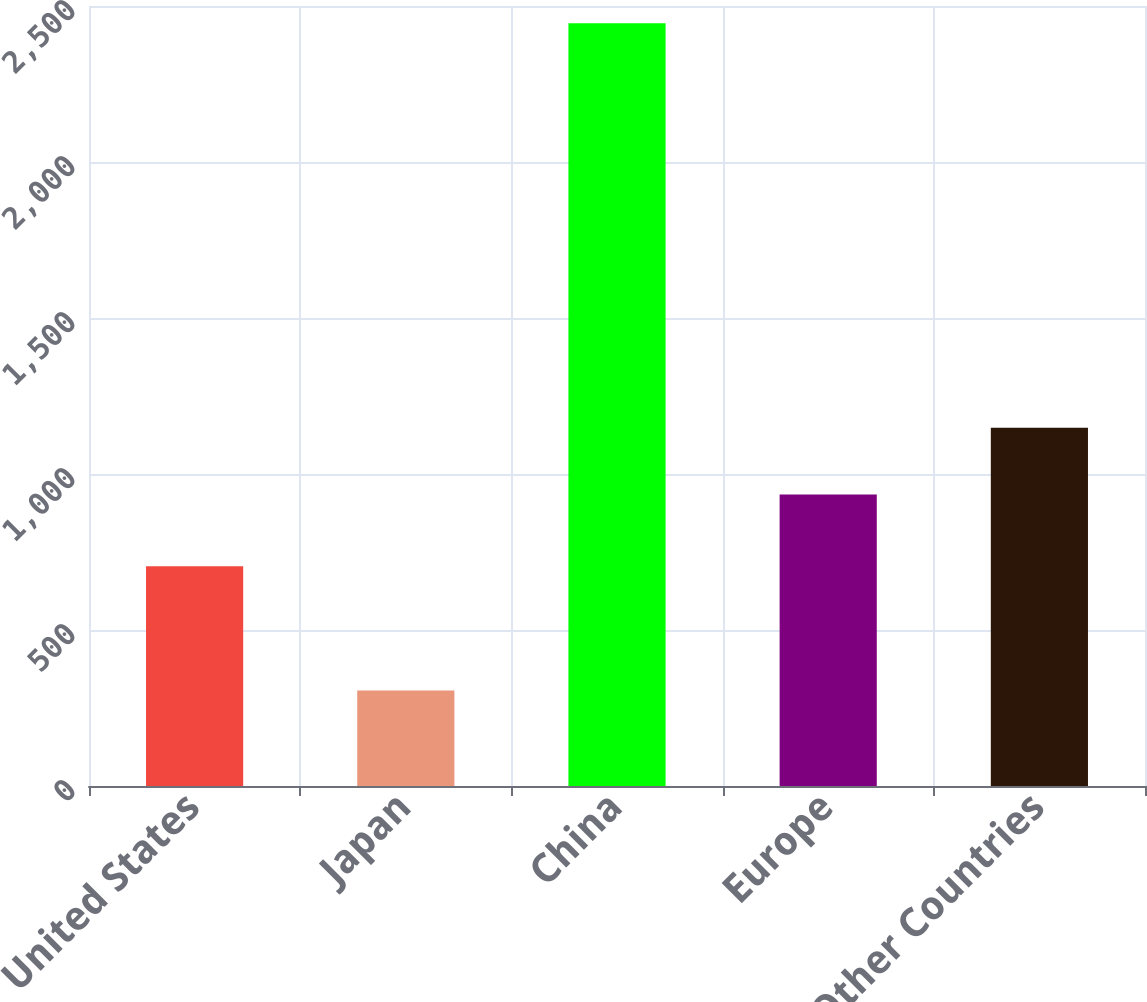<chart> <loc_0><loc_0><loc_500><loc_500><bar_chart><fcel>United States<fcel>Japan<fcel>China<fcel>Europe<fcel>Other Countries<nl><fcel>704<fcel>306<fcel>2445<fcel>934<fcel>1147.9<nl></chart> 